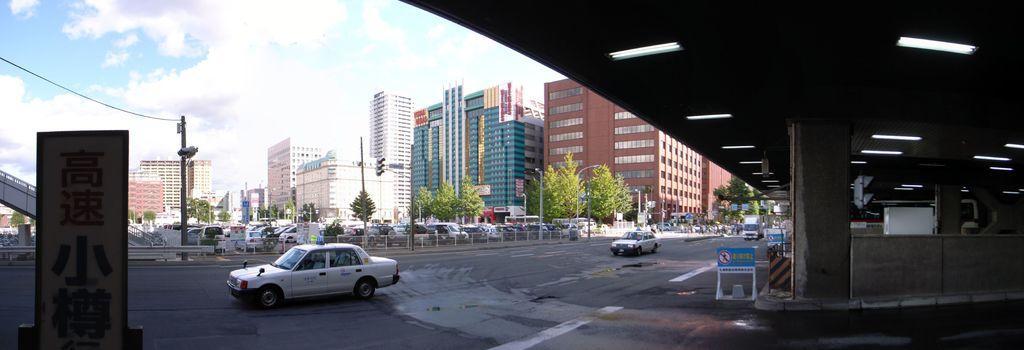Could you give a brief overview of what you see in this image? In this image I can see few buildings,trees,windows,poles,traffic signals,vehicles,fencing,sign boards and boards on the road. The sky is in white and blue color. 